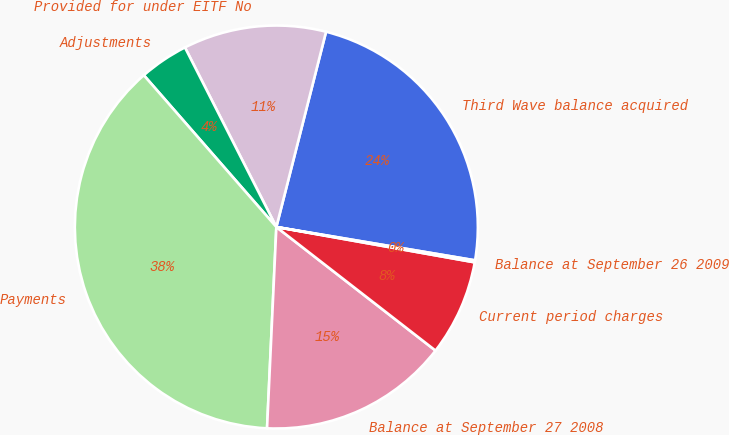Convert chart to OTSL. <chart><loc_0><loc_0><loc_500><loc_500><pie_chart><fcel>Third Wave balance acquired<fcel>Provided for under EITF No<fcel>Adjustments<fcel>Payments<fcel>Balance at September 27 2008<fcel>Current period charges<fcel>Balance at September 26 2009<nl><fcel>23.68%<fcel>11.46%<fcel>3.93%<fcel>37.84%<fcel>15.23%<fcel>7.7%<fcel>0.16%<nl></chart> 